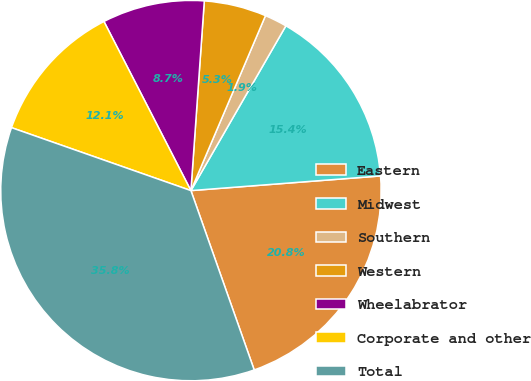Convert chart. <chart><loc_0><loc_0><loc_500><loc_500><pie_chart><fcel>Eastern<fcel>Midwest<fcel>Southern<fcel>Western<fcel>Wheelabrator<fcel>Corporate and other<fcel>Total<nl><fcel>20.83%<fcel>15.45%<fcel>1.91%<fcel>5.29%<fcel>8.68%<fcel>12.07%<fcel>35.77%<nl></chart> 